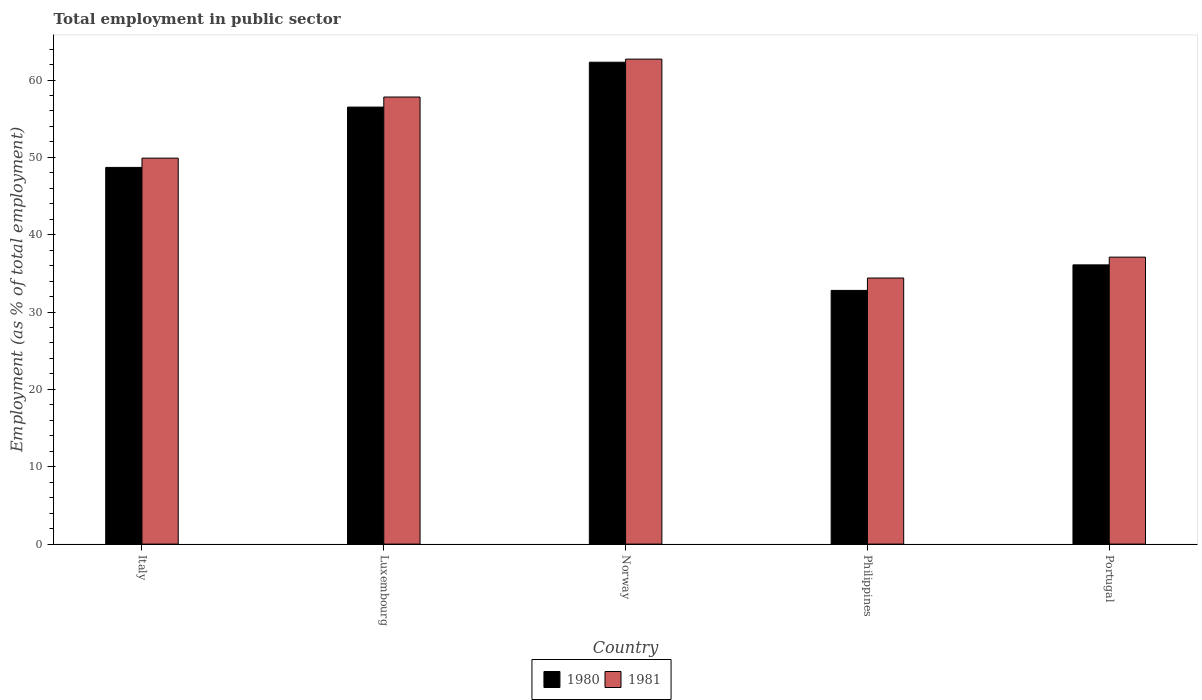How many bars are there on the 5th tick from the right?
Make the answer very short. 2. What is the label of the 1st group of bars from the left?
Your response must be concise. Italy. What is the employment in public sector in 1980 in Philippines?
Provide a succinct answer. 32.8. Across all countries, what is the maximum employment in public sector in 1981?
Offer a terse response. 62.7. Across all countries, what is the minimum employment in public sector in 1981?
Provide a succinct answer. 34.4. In which country was the employment in public sector in 1980 maximum?
Ensure brevity in your answer.  Norway. What is the total employment in public sector in 1981 in the graph?
Your answer should be compact. 241.9. What is the difference between the employment in public sector in 1981 in Italy and that in Luxembourg?
Offer a terse response. -7.9. What is the difference between the employment in public sector in 1980 in Norway and the employment in public sector in 1981 in Italy?
Give a very brief answer. 12.4. What is the average employment in public sector in 1981 per country?
Make the answer very short. 48.38. What is the difference between the employment in public sector of/in 1980 and employment in public sector of/in 1981 in Norway?
Provide a succinct answer. -0.4. In how many countries, is the employment in public sector in 1981 greater than 20 %?
Your answer should be very brief. 5. What is the ratio of the employment in public sector in 1980 in Luxembourg to that in Portugal?
Offer a very short reply. 1.57. Is the employment in public sector in 1981 in Italy less than that in Philippines?
Provide a succinct answer. No. Is the difference between the employment in public sector in 1980 in Luxembourg and Portugal greater than the difference between the employment in public sector in 1981 in Luxembourg and Portugal?
Your response must be concise. No. What is the difference between the highest and the second highest employment in public sector in 1980?
Your answer should be very brief. 7.8. What is the difference between the highest and the lowest employment in public sector in 1980?
Provide a short and direct response. 29.5. In how many countries, is the employment in public sector in 1981 greater than the average employment in public sector in 1981 taken over all countries?
Your answer should be compact. 3. What does the 2nd bar from the right in Luxembourg represents?
Ensure brevity in your answer.  1980. How many countries are there in the graph?
Offer a very short reply. 5. Does the graph contain grids?
Make the answer very short. No. Where does the legend appear in the graph?
Your answer should be very brief. Bottom center. What is the title of the graph?
Offer a very short reply. Total employment in public sector. What is the label or title of the Y-axis?
Your response must be concise. Employment (as % of total employment). What is the Employment (as % of total employment) in 1980 in Italy?
Provide a short and direct response. 48.7. What is the Employment (as % of total employment) in 1981 in Italy?
Provide a succinct answer. 49.9. What is the Employment (as % of total employment) in 1980 in Luxembourg?
Your answer should be very brief. 56.5. What is the Employment (as % of total employment) in 1981 in Luxembourg?
Offer a very short reply. 57.8. What is the Employment (as % of total employment) in 1980 in Norway?
Provide a succinct answer. 62.3. What is the Employment (as % of total employment) of 1981 in Norway?
Keep it short and to the point. 62.7. What is the Employment (as % of total employment) in 1980 in Philippines?
Provide a succinct answer. 32.8. What is the Employment (as % of total employment) in 1981 in Philippines?
Ensure brevity in your answer.  34.4. What is the Employment (as % of total employment) in 1980 in Portugal?
Offer a very short reply. 36.1. What is the Employment (as % of total employment) of 1981 in Portugal?
Provide a short and direct response. 37.1. Across all countries, what is the maximum Employment (as % of total employment) of 1980?
Offer a terse response. 62.3. Across all countries, what is the maximum Employment (as % of total employment) in 1981?
Offer a terse response. 62.7. Across all countries, what is the minimum Employment (as % of total employment) of 1980?
Make the answer very short. 32.8. Across all countries, what is the minimum Employment (as % of total employment) in 1981?
Keep it short and to the point. 34.4. What is the total Employment (as % of total employment) of 1980 in the graph?
Provide a succinct answer. 236.4. What is the total Employment (as % of total employment) of 1981 in the graph?
Your answer should be compact. 241.9. What is the difference between the Employment (as % of total employment) in 1981 in Italy and that in Luxembourg?
Make the answer very short. -7.9. What is the difference between the Employment (as % of total employment) in 1980 in Italy and that in Norway?
Offer a very short reply. -13.6. What is the difference between the Employment (as % of total employment) of 1981 in Italy and that in Philippines?
Provide a short and direct response. 15.5. What is the difference between the Employment (as % of total employment) of 1981 in Italy and that in Portugal?
Offer a terse response. 12.8. What is the difference between the Employment (as % of total employment) of 1981 in Luxembourg and that in Norway?
Give a very brief answer. -4.9. What is the difference between the Employment (as % of total employment) of 1980 in Luxembourg and that in Philippines?
Offer a very short reply. 23.7. What is the difference between the Employment (as % of total employment) in 1981 in Luxembourg and that in Philippines?
Provide a succinct answer. 23.4. What is the difference between the Employment (as % of total employment) of 1980 in Luxembourg and that in Portugal?
Offer a very short reply. 20.4. What is the difference between the Employment (as % of total employment) in 1981 in Luxembourg and that in Portugal?
Provide a succinct answer. 20.7. What is the difference between the Employment (as % of total employment) in 1980 in Norway and that in Philippines?
Give a very brief answer. 29.5. What is the difference between the Employment (as % of total employment) of 1981 in Norway and that in Philippines?
Make the answer very short. 28.3. What is the difference between the Employment (as % of total employment) in 1980 in Norway and that in Portugal?
Give a very brief answer. 26.2. What is the difference between the Employment (as % of total employment) of 1981 in Norway and that in Portugal?
Your answer should be compact. 25.6. What is the difference between the Employment (as % of total employment) of 1980 in Philippines and that in Portugal?
Provide a succinct answer. -3.3. What is the difference between the Employment (as % of total employment) in 1981 in Philippines and that in Portugal?
Ensure brevity in your answer.  -2.7. What is the difference between the Employment (as % of total employment) in 1980 in Italy and the Employment (as % of total employment) in 1981 in Luxembourg?
Offer a terse response. -9.1. What is the difference between the Employment (as % of total employment) in 1980 in Italy and the Employment (as % of total employment) in 1981 in Philippines?
Ensure brevity in your answer.  14.3. What is the difference between the Employment (as % of total employment) in 1980 in Luxembourg and the Employment (as % of total employment) in 1981 in Philippines?
Keep it short and to the point. 22.1. What is the difference between the Employment (as % of total employment) in 1980 in Luxembourg and the Employment (as % of total employment) in 1981 in Portugal?
Your answer should be very brief. 19.4. What is the difference between the Employment (as % of total employment) of 1980 in Norway and the Employment (as % of total employment) of 1981 in Philippines?
Make the answer very short. 27.9. What is the difference between the Employment (as % of total employment) in 1980 in Norway and the Employment (as % of total employment) in 1981 in Portugal?
Provide a succinct answer. 25.2. What is the average Employment (as % of total employment) in 1980 per country?
Your answer should be compact. 47.28. What is the average Employment (as % of total employment) in 1981 per country?
Your answer should be very brief. 48.38. What is the difference between the Employment (as % of total employment) in 1980 and Employment (as % of total employment) in 1981 in Philippines?
Provide a short and direct response. -1.6. What is the ratio of the Employment (as % of total employment) of 1980 in Italy to that in Luxembourg?
Offer a very short reply. 0.86. What is the ratio of the Employment (as % of total employment) of 1981 in Italy to that in Luxembourg?
Provide a short and direct response. 0.86. What is the ratio of the Employment (as % of total employment) in 1980 in Italy to that in Norway?
Provide a succinct answer. 0.78. What is the ratio of the Employment (as % of total employment) of 1981 in Italy to that in Norway?
Keep it short and to the point. 0.8. What is the ratio of the Employment (as % of total employment) of 1980 in Italy to that in Philippines?
Offer a very short reply. 1.48. What is the ratio of the Employment (as % of total employment) of 1981 in Italy to that in Philippines?
Provide a short and direct response. 1.45. What is the ratio of the Employment (as % of total employment) in 1980 in Italy to that in Portugal?
Give a very brief answer. 1.35. What is the ratio of the Employment (as % of total employment) of 1981 in Italy to that in Portugal?
Provide a succinct answer. 1.34. What is the ratio of the Employment (as % of total employment) in 1980 in Luxembourg to that in Norway?
Ensure brevity in your answer.  0.91. What is the ratio of the Employment (as % of total employment) in 1981 in Luxembourg to that in Norway?
Offer a terse response. 0.92. What is the ratio of the Employment (as % of total employment) of 1980 in Luxembourg to that in Philippines?
Ensure brevity in your answer.  1.72. What is the ratio of the Employment (as % of total employment) in 1981 in Luxembourg to that in Philippines?
Give a very brief answer. 1.68. What is the ratio of the Employment (as % of total employment) of 1980 in Luxembourg to that in Portugal?
Your response must be concise. 1.57. What is the ratio of the Employment (as % of total employment) in 1981 in Luxembourg to that in Portugal?
Offer a terse response. 1.56. What is the ratio of the Employment (as % of total employment) of 1980 in Norway to that in Philippines?
Give a very brief answer. 1.9. What is the ratio of the Employment (as % of total employment) of 1981 in Norway to that in Philippines?
Give a very brief answer. 1.82. What is the ratio of the Employment (as % of total employment) in 1980 in Norway to that in Portugal?
Your answer should be very brief. 1.73. What is the ratio of the Employment (as % of total employment) in 1981 in Norway to that in Portugal?
Provide a short and direct response. 1.69. What is the ratio of the Employment (as % of total employment) in 1980 in Philippines to that in Portugal?
Offer a very short reply. 0.91. What is the ratio of the Employment (as % of total employment) in 1981 in Philippines to that in Portugal?
Make the answer very short. 0.93. What is the difference between the highest and the second highest Employment (as % of total employment) of 1981?
Provide a short and direct response. 4.9. What is the difference between the highest and the lowest Employment (as % of total employment) in 1980?
Provide a succinct answer. 29.5. What is the difference between the highest and the lowest Employment (as % of total employment) of 1981?
Ensure brevity in your answer.  28.3. 